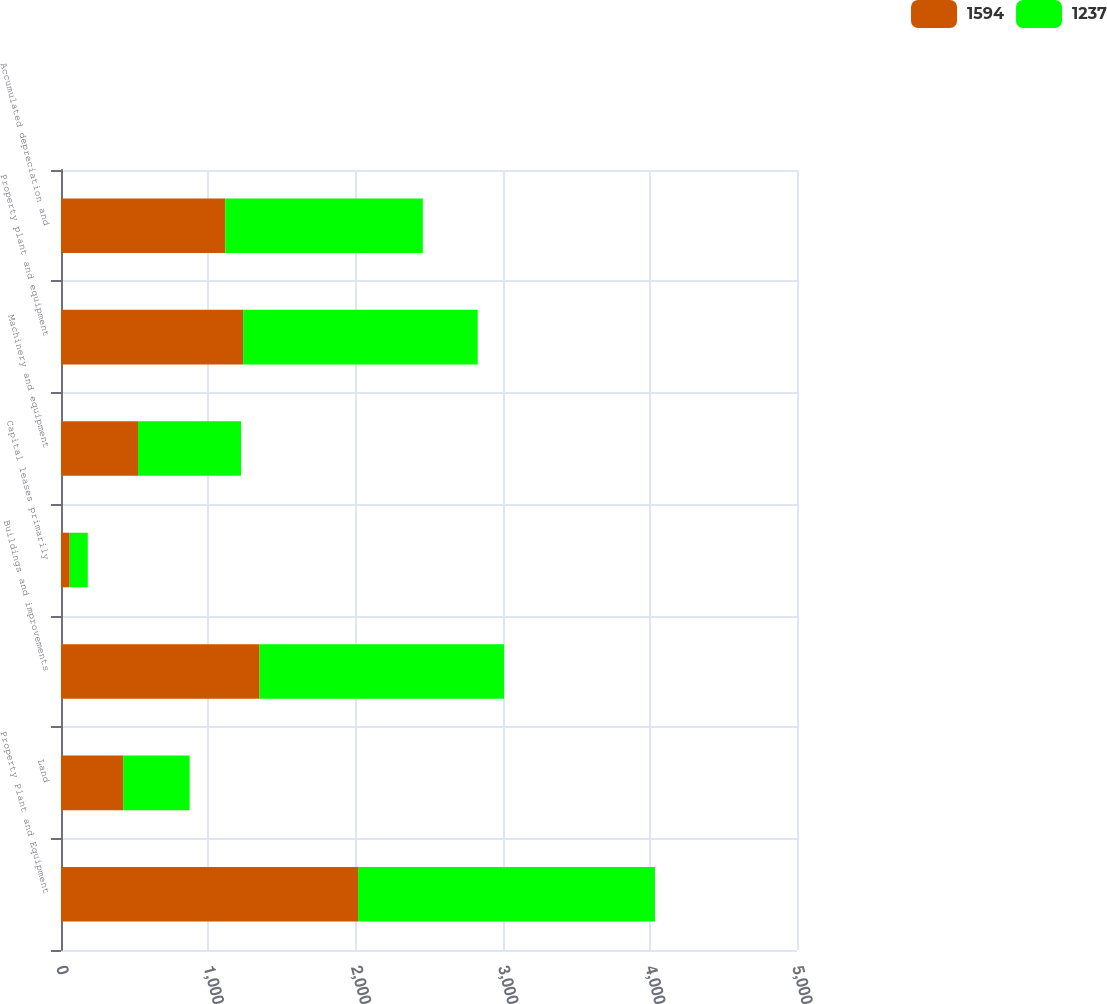Convert chart. <chart><loc_0><loc_0><loc_500><loc_500><stacked_bar_chart><ecel><fcel>Property Plant and Equipment<fcel>Land<fcel>Buildings and improvements<fcel>Capital leases primarily<fcel>Machinery and equipment<fcel>Property plant and equipment<fcel>Accumulated depreciation and<nl><fcel>1594<fcel>2018<fcel>422<fcel>1349<fcel>59<fcel>523<fcel>1237<fcel>1116<nl><fcel>1237<fcel>2017<fcel>452<fcel>1661<fcel>123<fcel>700<fcel>1594<fcel>1342<nl></chart> 